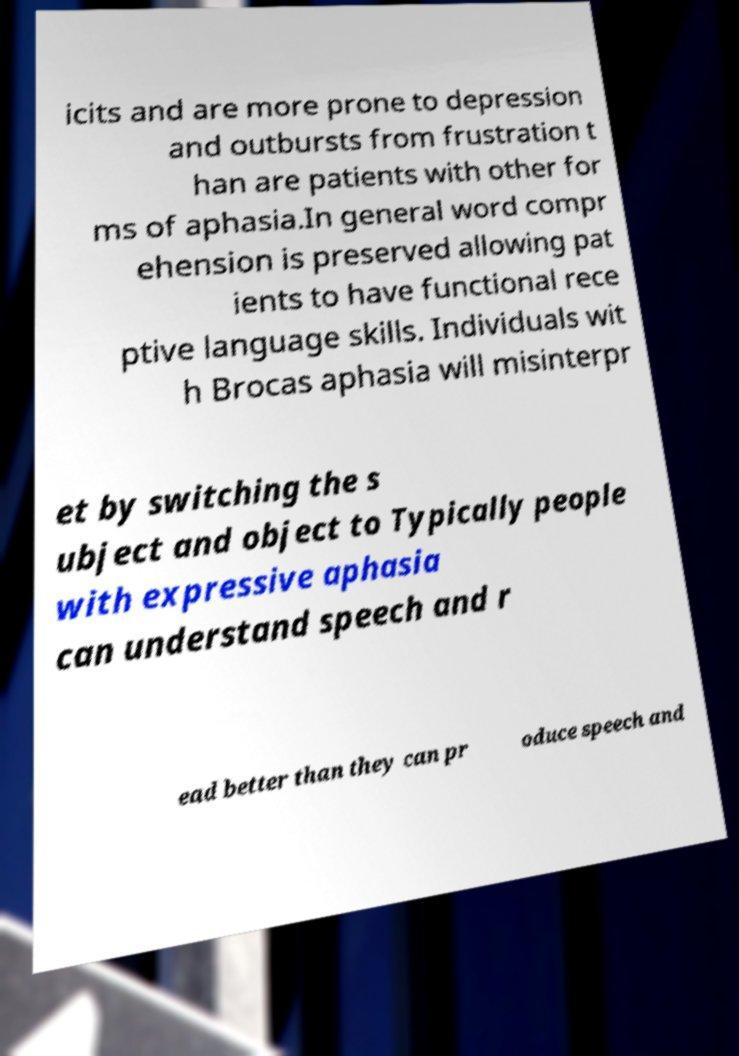Could you assist in decoding the text presented in this image and type it out clearly? icits and are more prone to depression and outbursts from frustration t han are patients with other for ms of aphasia.In general word compr ehension is preserved allowing pat ients to have functional rece ptive language skills. Individuals wit h Brocas aphasia will misinterpr et by switching the s ubject and object to Typically people with expressive aphasia can understand speech and r ead better than they can pr oduce speech and 